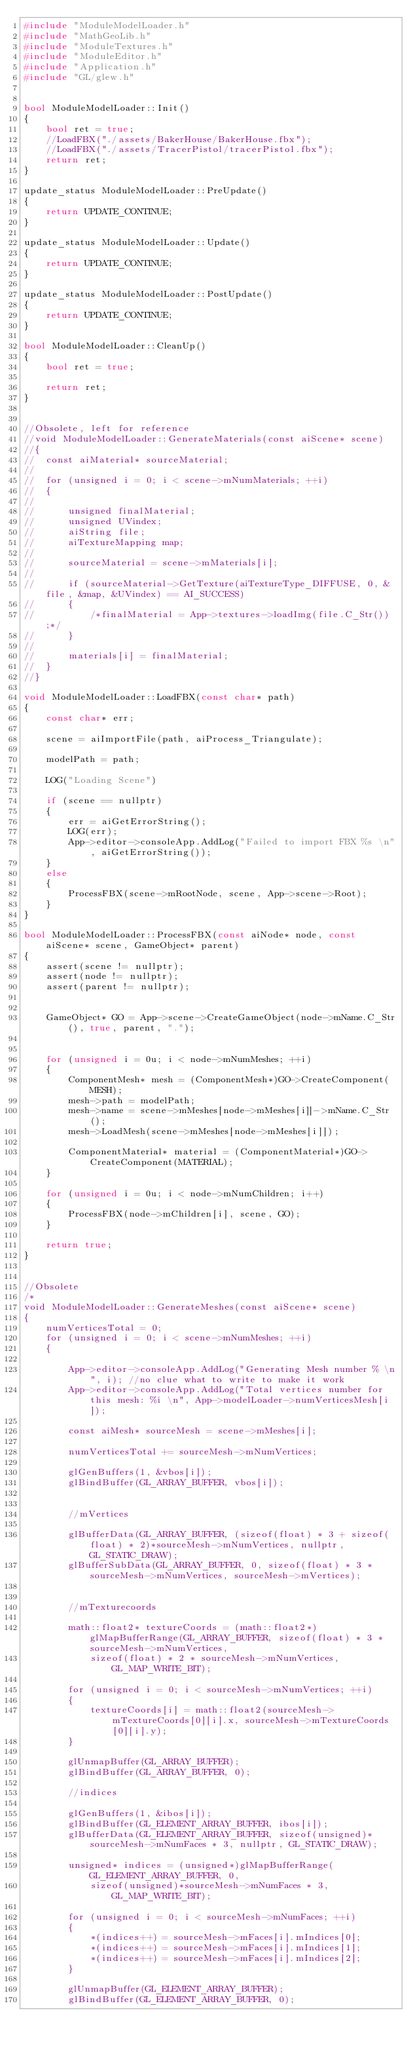<code> <loc_0><loc_0><loc_500><loc_500><_C++_>#include "ModuleModelLoader.h"
#include "MathGeoLib.h"
#include "ModuleTextures.h"
#include "ModuleEditor.h"
#include "Application.h"
#include "GL/glew.h"


bool ModuleModelLoader::Init()
{
	bool ret = true;
	//LoadFBX("./assets/BakerHouse/BakerHouse.fbx");
	//LoadFBX("./assets/TracerPistol/tracerPistol.fbx");
	return ret;
}

update_status ModuleModelLoader::PreUpdate()
{
	return UPDATE_CONTINUE;
}

update_status ModuleModelLoader::Update()
{
	return UPDATE_CONTINUE;
}

update_status ModuleModelLoader::PostUpdate()
{
	return UPDATE_CONTINUE;
}

bool ModuleModelLoader::CleanUp()
{
	bool ret = true;

	return ret;
}


//Obsolete, left for reference
//void ModuleModelLoader::GenerateMaterials(const aiScene* scene)
//{
//	const aiMaterial* sourceMaterial;
//
//	for (unsigned i = 0; i < scene->mNumMaterials; ++i)
//	{
//
//		unsigned finalMaterial;
//		unsigned UVindex;
//		aiString file;
//		aiTextureMapping map;
//
//		sourceMaterial = scene->mMaterials[i];
//
//		if (sourceMaterial->GetTexture(aiTextureType_DIFFUSE, 0, &file, &map, &UVindex) == AI_SUCCESS)
//		{
//			/*finalMaterial = App->textures->loadImg(file.C_Str());*/
//		}
//
//		materials[i] = finalMaterial;
//	}
//}

void ModuleModelLoader::LoadFBX(const char* path)
{
	const char* err;

	scene = aiImportFile(path, aiProcess_Triangulate);

	modelPath = path;

	LOG("Loading Scene")

	if (scene == nullptr)
	{
		err = aiGetErrorString();
		LOG(err);
		App->editor->consoleApp.AddLog("Failed to import FBX %s \n", aiGetErrorString());
	}
	else
	{
		ProcessFBX(scene->mRootNode, scene, App->scene->Root);
	}
}

bool ModuleModelLoader::ProcessFBX(const aiNode* node, const aiScene* scene, GameObject* parent)
{
	assert(scene != nullptr);
	assert(node != nullptr);
	assert(parent != nullptr);


	GameObject* GO = App->scene->CreateGameObject(node->mName.C_Str(), true, parent, ".");


	for (unsigned i = 0u; i < node->mNumMeshes; ++i) 
	{
		ComponentMesh* mesh = (ComponentMesh*)GO->CreateComponent(MESH);
		mesh->path = modelPath;
		mesh->name = scene->mMeshes[node->mMeshes[i]]->mName.C_Str();
		mesh->LoadMesh(scene->mMeshes[node->mMeshes[i]]);

		ComponentMaterial* material = (ComponentMaterial*)GO->CreateComponent(MATERIAL);
	}

	for (unsigned i = 0u; i < node->mNumChildren; i++) 
	{
		ProcessFBX(node->mChildren[i], scene, GO);
	}

	return true;
}	


//Obsolete
/*
void ModuleModelLoader::GenerateMeshes(const aiScene* scene)
{
	numVerticesTotal = 0;
	for (unsigned i = 0; i < scene->mNumMeshes; ++i)
	{

		App->editor->consoleApp.AddLog("Generating Mesh number % \n", i); //no clue what to write to make it work
		App->editor->consoleApp.AddLog("Total vertices number for this mesh: %i \n", App->modelLoader->numVerticesMesh[i]);

		const aiMesh* sourceMesh = scene->mMeshes[i];

		numVerticesTotal += sourceMesh->mNumVertices;

		glGenBuffers(1, &vbos[i]);
		glBindBuffer(GL_ARRAY_BUFFER, vbos[i]);


		//mVertices

		glBufferData(GL_ARRAY_BUFFER, (sizeof(float) * 3 + sizeof(float) * 2)*sourceMesh->mNumVertices, nullptr, GL_STATIC_DRAW);
		glBufferSubData(GL_ARRAY_BUFFER, 0, sizeof(float) * 3 * sourceMesh->mNumVertices, sourceMesh->mVertices);


		//mTexturecoords

		math::float2* textureCoords = (math::float2*)glMapBufferRange(GL_ARRAY_BUFFER, sizeof(float) * 3 * sourceMesh->mNumVertices,
			sizeof(float) * 2 * sourceMesh->mNumVertices, GL_MAP_WRITE_BIT);

		for (unsigned i = 0; i < sourceMesh->mNumVertices; ++i)
		{
			textureCoords[i] = math::float2(sourceMesh->mTextureCoords[0][i].x, sourceMesh->mTextureCoords[0][i].y);
		}

		glUnmapBuffer(GL_ARRAY_BUFFER);
		glBindBuffer(GL_ARRAY_BUFFER, 0);

		//indices

		glGenBuffers(1, &ibos[i]);
		glBindBuffer(GL_ELEMENT_ARRAY_BUFFER, ibos[i]);
		glBufferData(GL_ELEMENT_ARRAY_BUFFER, sizeof(unsigned)*sourceMesh->mNumFaces * 3, nullptr, GL_STATIC_DRAW);

		unsigned* indices = (unsigned*)glMapBufferRange(GL_ELEMENT_ARRAY_BUFFER, 0,
			sizeof(unsigned)*sourceMesh->mNumFaces * 3, GL_MAP_WRITE_BIT);

		for (unsigned i = 0; i < sourceMesh->mNumFaces; ++i)
		{
			*(indices++) = sourceMesh->mFaces[i].mIndices[0];
			*(indices++) = sourceMesh->mFaces[i].mIndices[1];
			*(indices++) = sourceMesh->mFaces[i].mIndices[2];
		}

		glUnmapBuffer(GL_ELEMENT_ARRAY_BUFFER);
		glBindBuffer(GL_ELEMENT_ARRAY_BUFFER, 0);
</code> 